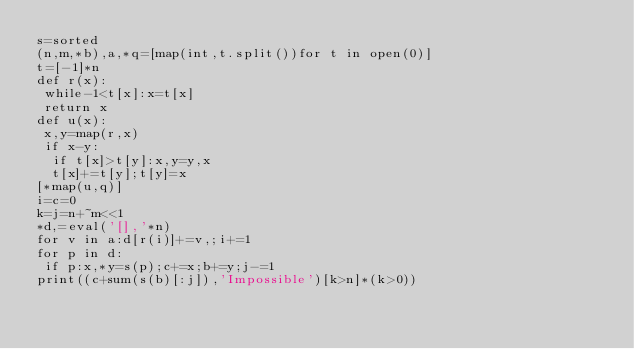<code> <loc_0><loc_0><loc_500><loc_500><_Python_>s=sorted
(n,m,*b),a,*q=[map(int,t.split())for t in open(0)]
t=[-1]*n
def r(x):
 while-1<t[x]:x=t[x]
 return x
def u(x):
 x,y=map(r,x)
 if x-y:
  if t[x]>t[y]:x,y=y,x
  t[x]+=t[y];t[y]=x
[*map(u,q)]
i=c=0
k=j=n+~m<<1
*d,=eval('[],'*n)
for v in a:d[r(i)]+=v,;i+=1
for p in d:
 if p:x,*y=s(p);c+=x;b+=y;j-=1
print((c+sum(s(b)[:j]),'Impossible')[k>n]*(k>0))</code> 